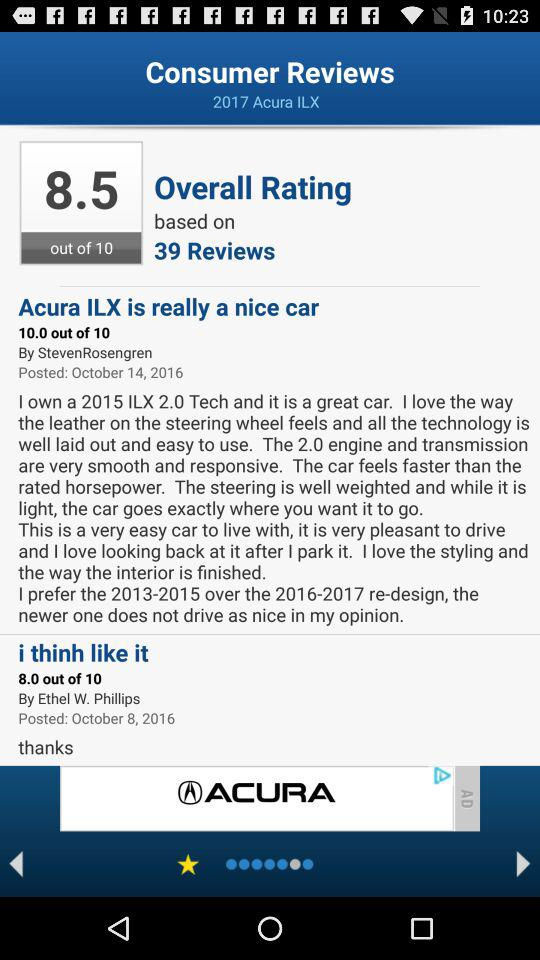How many rating points did Ethel W. Phillips give? Ethel W. Phillips gave 8.0 rating points. 